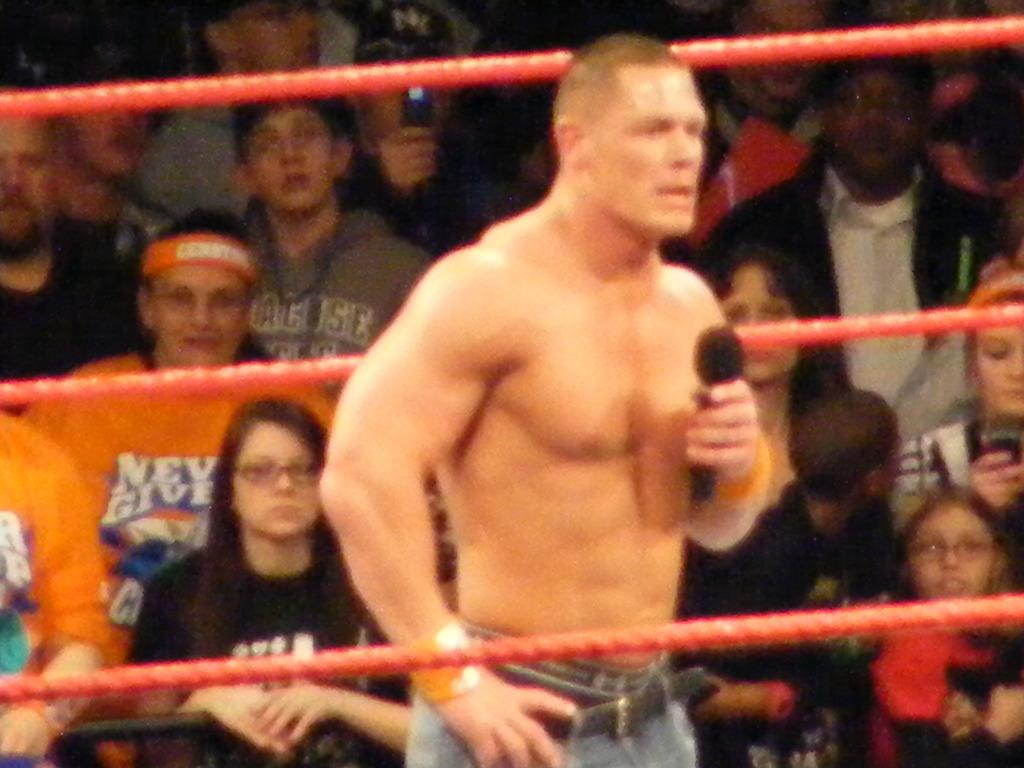How many people are in the image? There is a group of people in the image. What are the people in the image doing? The people are sitting. Can you describe the man in the front of the group? The man in the front of the group is holding a microphone. What type of milk is the man pouring into the microphone in the image? There is no milk or pouring action present in the image; the man is holding a microphone. Can you describe the maid in the image? There is no maid present in the image. 